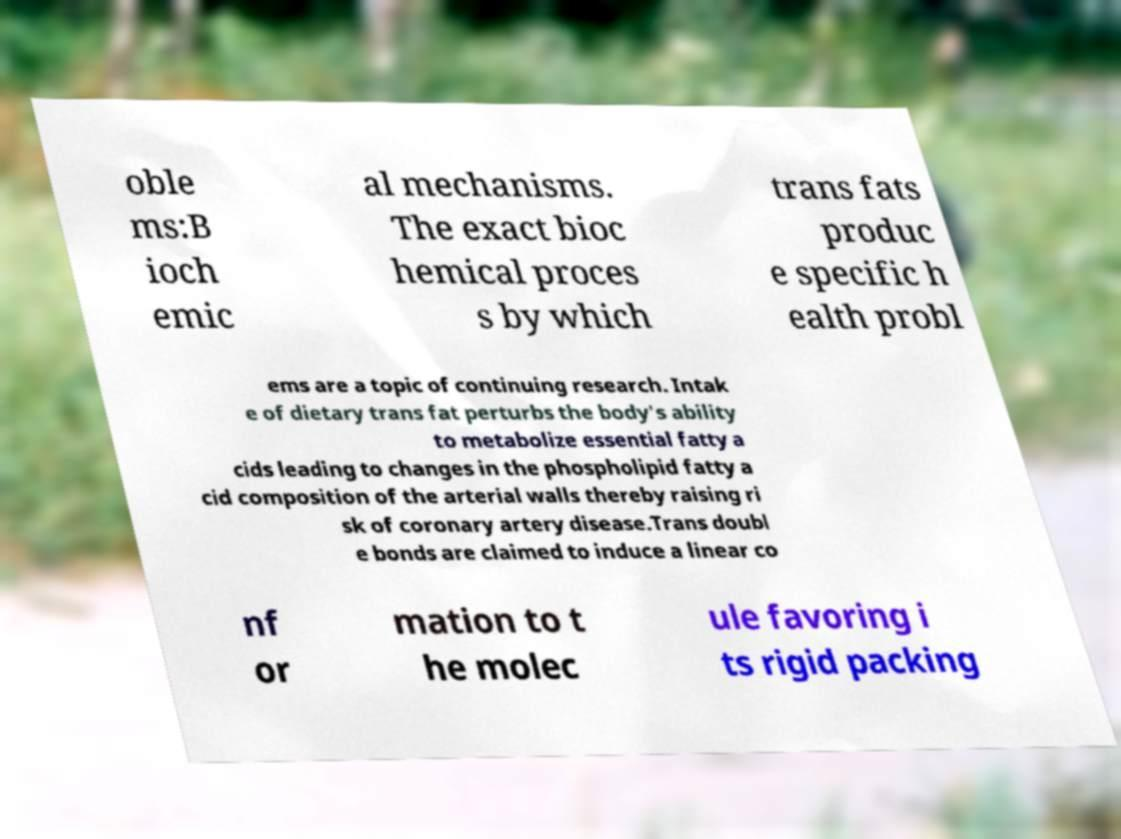Please read and relay the text visible in this image. What does it say? oble ms:B ioch emic al mechanisms. The exact bioc hemical proces s by which trans fats produc e specific h ealth probl ems are a topic of continuing research. Intak e of dietary trans fat perturbs the body's ability to metabolize essential fatty a cids leading to changes in the phospholipid fatty a cid composition of the arterial walls thereby raising ri sk of coronary artery disease.Trans doubl e bonds are claimed to induce a linear co nf or mation to t he molec ule favoring i ts rigid packing 